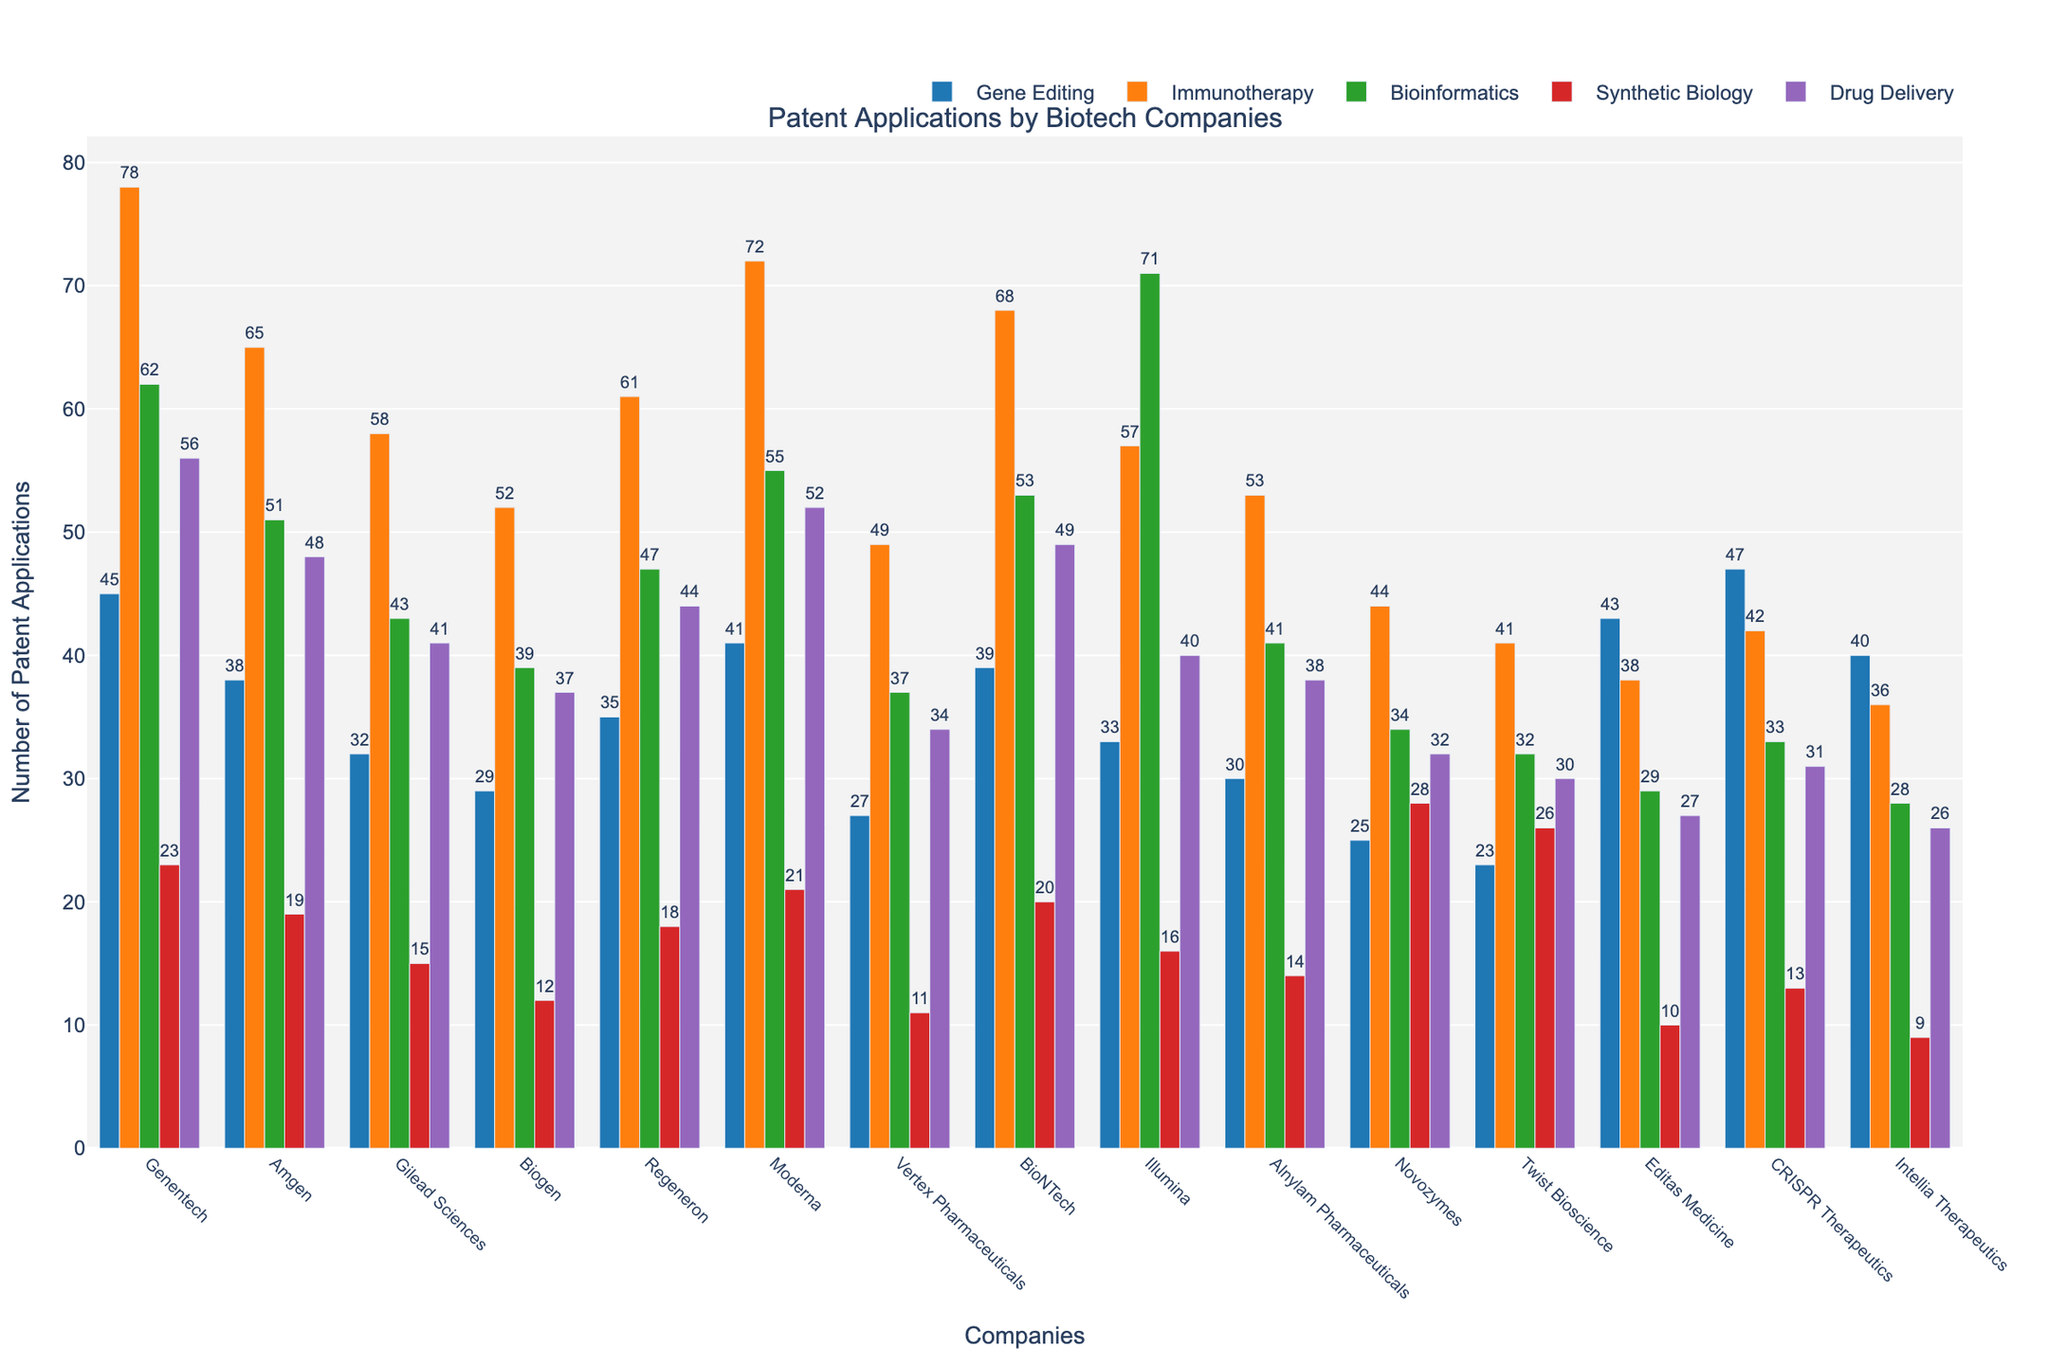What company has the highest number of patent applications in Immunotherapy? Look for the tallest bar in the Immunotherapy section (orange bars). Genentech has the highest with 78 patent applications.
Answer: Genentech Which company filed the least number of patent applications in Synthetic Biology? Look for the shortest bar in the Synthetic Biology section (purple bars). Intellia Therapeutics has the least with 9 patent applications.
Answer: Intellia Therapeutics Which companies have filed more than 60 patent applications specifically in Bioinformatics? Examine the height of the green bars for each company. Genentech, Illumina, and BioNTech each filed more than 60 Bioinformatics patents.
Answer: Genentech, Illumina, BioNTech Compare the total number of patent applications filed by Genentech and Amgen. Which company has a higher total? Sum the values for each technology type for both companies. Genentech: 45+78+62+23+56 = 264; Amgen: 38+65+51+19+48 = 221. Genentech has the higher total.
Answer: Genentech Among Gene Editing and Drug Delivery, which technology type had more patents filed by CRISPR Therapeutics? Compare the heights of the blue (Gene Editing) and purple (Drug Delivery) bars for CRISPR Therapeutics. Gene Editing has 47, and Drug Delivery has 31 patents.
Answer: Gene Editing What is the difference in the number of Bioinformatics patents filed between Illumina and Intellia Therapeutics? Look at the green bars for Illumina and Intellia Therapeutics. Illumina has 71, Intellia Therapeutics has 28. Subtract 28 from 71.
Answer: 43 Which company has the most evenly distributed number of patent applications across all five technology types? Visually compare the heights of the bars for each company to see which has the most similar heights across all categories. Companies like Genentech and Moderna appear to have relatively even distributions.
Answer: Genentech, Moderna What is the total number of patent applications filed in Immunotherapy across all companies? Add the values for the orange bars for all companies. 78+65+58+52+61+72+49+68+57+53+44+41+38+42+36 = 816.
Answer: 816 How does Twist Bioscience's total patent applications compare to Biogen? Sum the values across all categories for both companies. Twist Bioscience: 23+41+32+26+30 = 152; Biogen: 29+52+39+12+37 = 169. Biogen has more.
Answer: Biogen Which technology has the widest range of patent applications filed across all companies (i.e., the largest difference between the highest and lowest number of patents)? Calculate the range for each technology type. Gene Editing: 47-23, Immunotherapy: 78-36, Bioinformatics: 71-28, Synthetic Biology: 28-9, Drug Delivery: 56-26. Immunotherapy has the widest range of 42.
Answer: Immunotherapy 